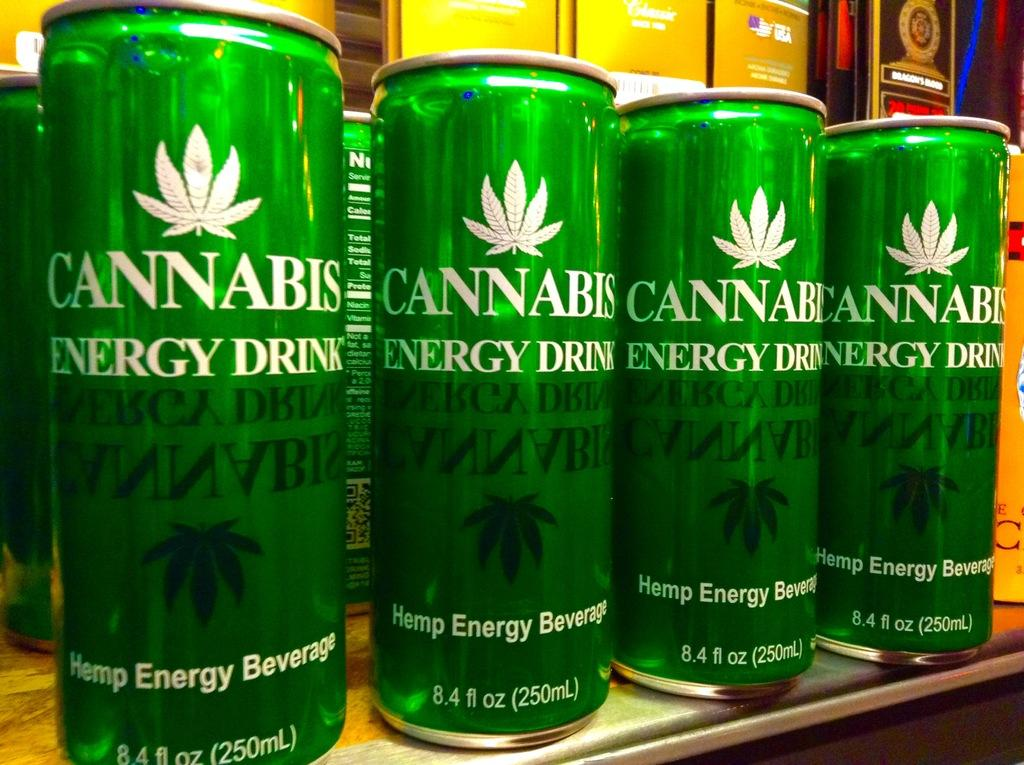Provide a one-sentence caption for the provided image. Green Cannabis Energy drink cans aligned on the rack from Hamp Energy Beverage firf. 